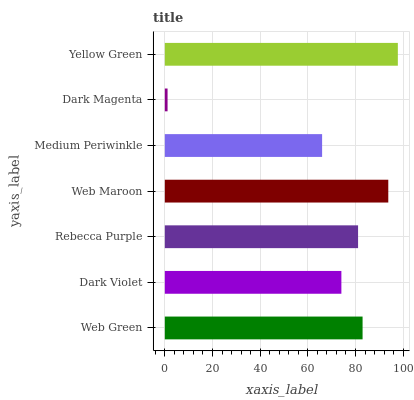Is Dark Magenta the minimum?
Answer yes or no. Yes. Is Yellow Green the maximum?
Answer yes or no. Yes. Is Dark Violet the minimum?
Answer yes or no. No. Is Dark Violet the maximum?
Answer yes or no. No. Is Web Green greater than Dark Violet?
Answer yes or no. Yes. Is Dark Violet less than Web Green?
Answer yes or no. Yes. Is Dark Violet greater than Web Green?
Answer yes or no. No. Is Web Green less than Dark Violet?
Answer yes or no. No. Is Rebecca Purple the high median?
Answer yes or no. Yes. Is Rebecca Purple the low median?
Answer yes or no. Yes. Is Dark Magenta the high median?
Answer yes or no. No. Is Web Green the low median?
Answer yes or no. No. 